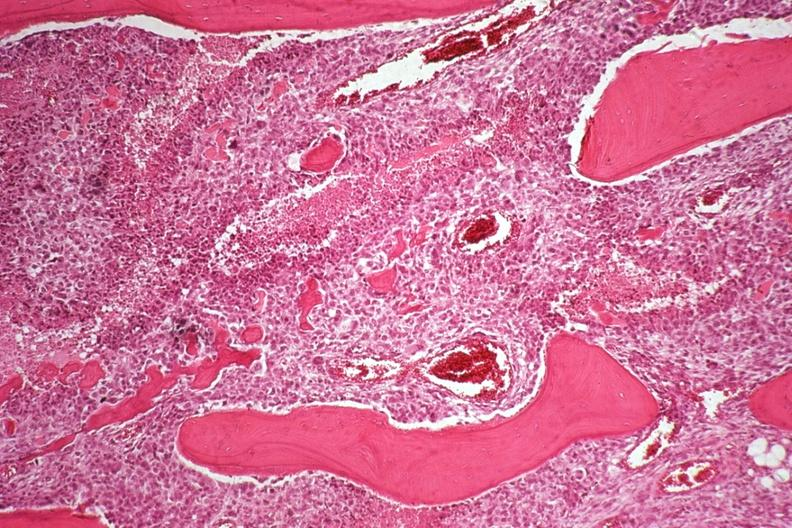s joints present?
Answer the question using a single word or phrase. Yes 